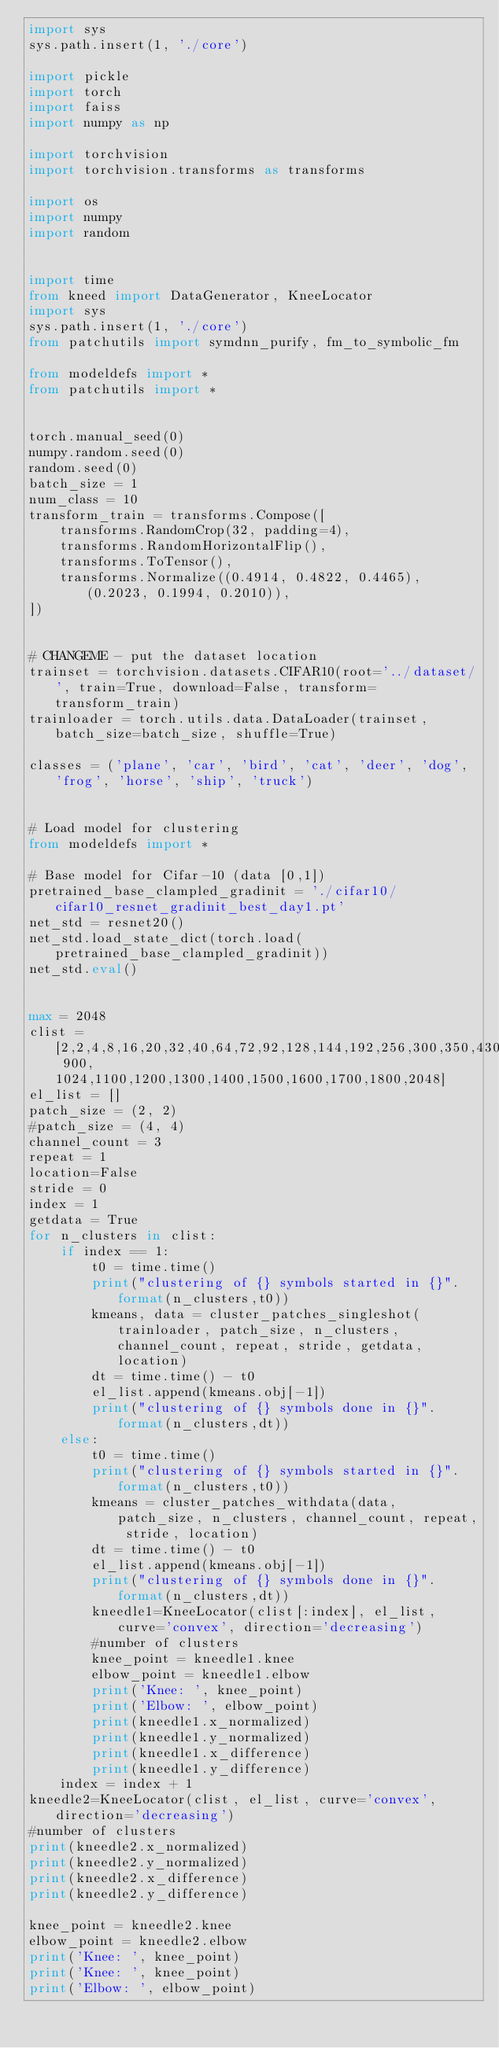Convert code to text. <code><loc_0><loc_0><loc_500><loc_500><_Python_>import sys
sys.path.insert(1, './core')

import pickle
import torch
import faiss 
import numpy as np

import torchvision
import torchvision.transforms as transforms

import os
import numpy
import random


import time
from kneed import DataGenerator, KneeLocator
import sys 
sys.path.insert(1, './core')
from patchutils import symdnn_purify, fm_to_symbolic_fm

from modeldefs import *
from patchutils import *


torch.manual_seed(0)
numpy.random.seed(0)
random.seed(0)
batch_size = 1 
num_class = 10
transform_train = transforms.Compose([
    transforms.RandomCrop(32, padding=4),
    transforms.RandomHorizontalFlip(),
    transforms.ToTensor(),
    transforms.Normalize((0.4914, 0.4822, 0.4465), (0.2023, 0.1994, 0.2010)),
])


# CHANGEME - put the dataset location 
trainset = torchvision.datasets.CIFAR10(root='../dataset/', train=True, download=False, transform=transform_train)
trainloader = torch.utils.data.DataLoader(trainset, batch_size=batch_size, shuffle=True)

classes = ('plane', 'car', 'bird', 'cat', 'deer', 'dog', 'frog', 'horse', 'ship', 'truck')


# Load model for clustering
from modeldefs import *

# Base model for Cifar-10 (data [0,1])
pretrained_base_clampled_gradinit = './cifar10/cifar10_resnet_gradinit_best_day1.pt'
net_std = resnet20()
net_std.load_state_dict(torch.load(pretrained_base_clampled_gradinit))
net_std.eval()


max = 2048
clist = [2,2,4,8,16,20,32,40,64,72,92,128,144,192,256,300,350,430,512,700,800, 900, 1024,1100,1200,1300,1400,1500,1600,1700,1800,2048]
el_list = []
patch_size = (2, 2)
#patch_size = (4, 4)
channel_count = 3
repeat = 1
location=False
stride = 0
index = 1
getdata = True
for n_clusters in clist:
    if index == 1:
        t0 = time.time()
        print("clustering of {} symbols started in {}".format(n_clusters,t0)) 
        kmeans, data = cluster_patches_singleshot(trainloader, patch_size, n_clusters, channel_count, repeat, stride, getdata, location)
        dt = time.time() - t0
        el_list.append(kmeans.obj[-1])
        print("clustering of {} symbols done in {}".format(n_clusters,dt))
    else: 
        t0 = time.time()
        print("clustering of {} symbols started in {}".format(n_clusters,t0)) 
        kmeans = cluster_patches_withdata(data, patch_size, n_clusters, channel_count, repeat, stride, location)
        dt = time.time() - t0
        el_list.append(kmeans.obj[-1])
        print("clustering of {} symbols done in {}".format(n_clusters,dt))
        kneedle1=KneeLocator(clist[:index], el_list, curve='convex', direction='decreasing')
        #number of clusters
        knee_point = kneedle1.knee 
        elbow_point = kneedle1.elbow
        print('Knee: ', knee_point) 
        print('Elbow: ', elbow_point)
        print(kneedle1.x_normalized)
        print(kneedle1.y_normalized)
        print(kneedle1.x_difference)
        print(kneedle1.y_difference)
    index = index + 1
kneedle2=KneeLocator(clist, el_list, curve='convex', direction='decreasing')
#number of clusters
print(kneedle2.x_normalized)
print(kneedle2.y_normalized)
print(kneedle2.x_difference)
print(kneedle2.y_difference)

knee_point = kneedle2.knee 
elbow_point = kneedle2.elbow
print('Knee: ', knee_point) 
print('Knee: ', knee_point) 
print('Elbow: ', elbow_point)
</code> 